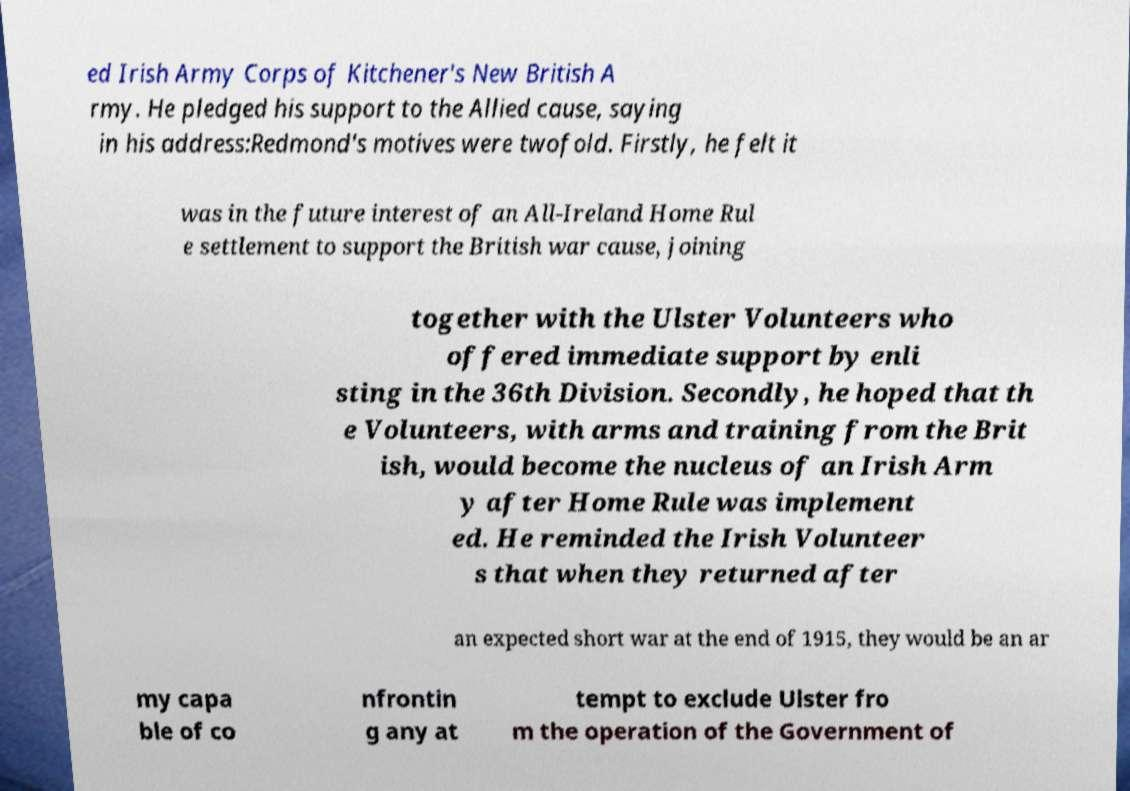There's text embedded in this image that I need extracted. Can you transcribe it verbatim? ed Irish Army Corps of Kitchener's New British A rmy. He pledged his support to the Allied cause, saying in his address:Redmond's motives were twofold. Firstly, he felt it was in the future interest of an All-Ireland Home Rul e settlement to support the British war cause, joining together with the Ulster Volunteers who offered immediate support by enli sting in the 36th Division. Secondly, he hoped that th e Volunteers, with arms and training from the Brit ish, would become the nucleus of an Irish Arm y after Home Rule was implement ed. He reminded the Irish Volunteer s that when they returned after an expected short war at the end of 1915, they would be an ar my capa ble of co nfrontin g any at tempt to exclude Ulster fro m the operation of the Government of 